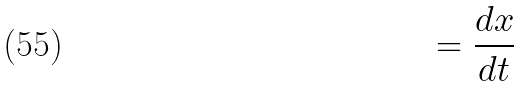<formula> <loc_0><loc_0><loc_500><loc_500>= \frac { d x } { d t }</formula> 